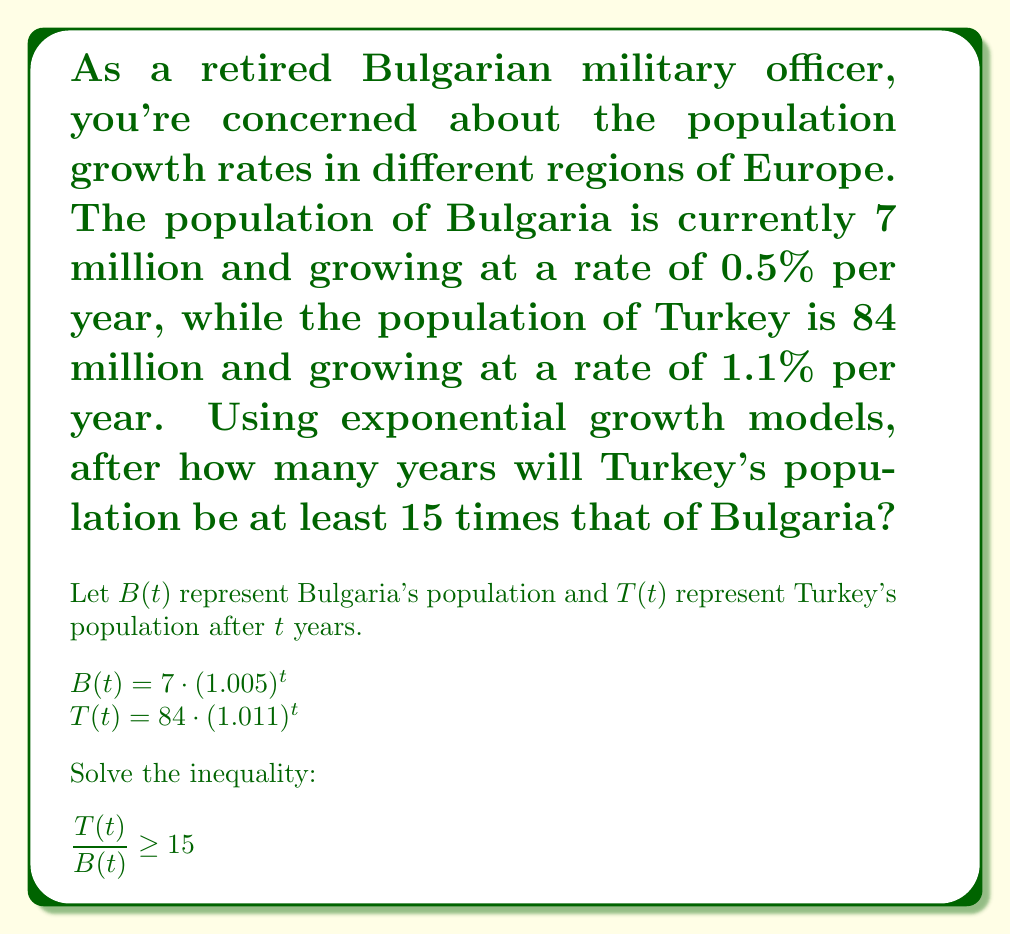Show me your answer to this math problem. To solve this problem, we'll follow these steps:

1) Set up the inequality:

   $\frac{T(t)}{B(t)} \geq 15$

2) Substitute the exponential growth models:

   $\frac{84 \cdot (1.011)^t}{7 \cdot (1.005)^t} \geq 15$

3) Simplify the left side:

   $12 \cdot \left(\frac{1.011}{1.005}\right)^t \geq 15$

4) Divide both sides by 12:

   $\left(\frac{1.011}{1.005}\right)^t \geq \frac{15}{12} = 1.25$

5) Take the natural logarithm of both sides:

   $t \cdot \ln\left(\frac{1.011}{1.005}\right) \geq \ln(1.25)$

6) Solve for $t$:

   $t \geq \frac{\ln(1.25)}{\ln(1.011) - \ln(1.005)}$

7) Calculate the result:

   $t \geq \frac{\ln(1.25)}{\ln(1.011) - \ln(1.005)} \approx 42.76$ years

8) Since we need a whole number of years, we round up to the next integer.
Answer: Turkey's population will be at least 15 times that of Bulgaria after 43 years. 